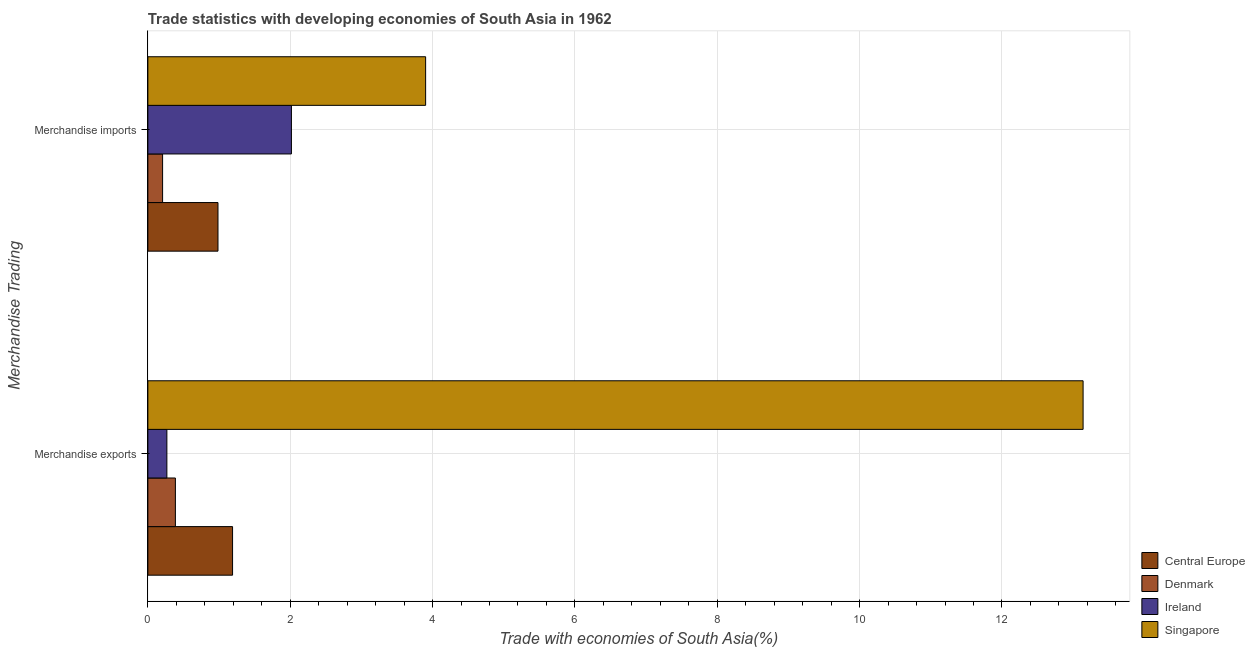How many different coloured bars are there?
Make the answer very short. 4. Are the number of bars per tick equal to the number of legend labels?
Make the answer very short. Yes. How many bars are there on the 1st tick from the top?
Your answer should be compact. 4. How many bars are there on the 2nd tick from the bottom?
Your response must be concise. 4. What is the label of the 2nd group of bars from the top?
Provide a succinct answer. Merchandise exports. What is the merchandise exports in Denmark?
Your answer should be very brief. 0.39. Across all countries, what is the maximum merchandise imports?
Make the answer very short. 3.9. Across all countries, what is the minimum merchandise imports?
Keep it short and to the point. 0.21. In which country was the merchandise imports maximum?
Provide a short and direct response. Singapore. In which country was the merchandise imports minimum?
Your response must be concise. Denmark. What is the total merchandise exports in the graph?
Provide a succinct answer. 14.98. What is the difference between the merchandise exports in Central Europe and that in Denmark?
Ensure brevity in your answer.  0.8. What is the difference between the merchandise exports in Denmark and the merchandise imports in Central Europe?
Provide a succinct answer. -0.6. What is the average merchandise exports per country?
Give a very brief answer. 3.75. What is the difference between the merchandise imports and merchandise exports in Singapore?
Ensure brevity in your answer.  -9.24. In how many countries, is the merchandise exports greater than 0.4 %?
Your answer should be very brief. 2. What is the ratio of the merchandise imports in Singapore to that in Ireland?
Make the answer very short. 1.93. What does the 2nd bar from the top in Merchandise exports represents?
Make the answer very short. Ireland. What does the 3rd bar from the bottom in Merchandise imports represents?
Provide a succinct answer. Ireland. How many bars are there?
Make the answer very short. 8. Are all the bars in the graph horizontal?
Provide a short and direct response. Yes. How many countries are there in the graph?
Offer a terse response. 4. Does the graph contain any zero values?
Give a very brief answer. No. Where does the legend appear in the graph?
Ensure brevity in your answer.  Bottom right. How many legend labels are there?
Keep it short and to the point. 4. What is the title of the graph?
Offer a terse response. Trade statistics with developing economies of South Asia in 1962. Does "Turkmenistan" appear as one of the legend labels in the graph?
Your answer should be compact. No. What is the label or title of the X-axis?
Provide a short and direct response. Trade with economies of South Asia(%). What is the label or title of the Y-axis?
Offer a terse response. Merchandise Trading. What is the Trade with economies of South Asia(%) of Central Europe in Merchandise exports?
Ensure brevity in your answer.  1.19. What is the Trade with economies of South Asia(%) of Denmark in Merchandise exports?
Ensure brevity in your answer.  0.39. What is the Trade with economies of South Asia(%) in Ireland in Merchandise exports?
Provide a succinct answer. 0.27. What is the Trade with economies of South Asia(%) of Singapore in Merchandise exports?
Offer a terse response. 13.14. What is the Trade with economies of South Asia(%) of Central Europe in Merchandise imports?
Keep it short and to the point. 0.99. What is the Trade with economies of South Asia(%) of Denmark in Merchandise imports?
Your answer should be very brief. 0.21. What is the Trade with economies of South Asia(%) of Ireland in Merchandise imports?
Offer a very short reply. 2.02. What is the Trade with economies of South Asia(%) of Singapore in Merchandise imports?
Your answer should be very brief. 3.9. Across all Merchandise Trading, what is the maximum Trade with economies of South Asia(%) of Central Europe?
Give a very brief answer. 1.19. Across all Merchandise Trading, what is the maximum Trade with economies of South Asia(%) of Denmark?
Your answer should be very brief. 0.39. Across all Merchandise Trading, what is the maximum Trade with economies of South Asia(%) in Ireland?
Your answer should be very brief. 2.02. Across all Merchandise Trading, what is the maximum Trade with economies of South Asia(%) of Singapore?
Make the answer very short. 13.14. Across all Merchandise Trading, what is the minimum Trade with economies of South Asia(%) of Central Europe?
Ensure brevity in your answer.  0.99. Across all Merchandise Trading, what is the minimum Trade with economies of South Asia(%) of Denmark?
Your answer should be compact. 0.21. Across all Merchandise Trading, what is the minimum Trade with economies of South Asia(%) in Ireland?
Ensure brevity in your answer.  0.27. Across all Merchandise Trading, what is the minimum Trade with economies of South Asia(%) in Singapore?
Provide a short and direct response. 3.9. What is the total Trade with economies of South Asia(%) of Central Europe in the graph?
Ensure brevity in your answer.  2.18. What is the total Trade with economies of South Asia(%) of Denmark in the graph?
Your answer should be compact. 0.59. What is the total Trade with economies of South Asia(%) of Ireland in the graph?
Your answer should be compact. 2.28. What is the total Trade with economies of South Asia(%) in Singapore in the graph?
Your response must be concise. 17.04. What is the difference between the Trade with economies of South Asia(%) in Central Europe in Merchandise exports and that in Merchandise imports?
Your answer should be compact. 0.2. What is the difference between the Trade with economies of South Asia(%) in Denmark in Merchandise exports and that in Merchandise imports?
Your response must be concise. 0.18. What is the difference between the Trade with economies of South Asia(%) of Ireland in Merchandise exports and that in Merchandise imports?
Offer a very short reply. -1.75. What is the difference between the Trade with economies of South Asia(%) in Singapore in Merchandise exports and that in Merchandise imports?
Your answer should be compact. 9.24. What is the difference between the Trade with economies of South Asia(%) in Central Europe in Merchandise exports and the Trade with economies of South Asia(%) in Denmark in Merchandise imports?
Provide a succinct answer. 0.98. What is the difference between the Trade with economies of South Asia(%) of Central Europe in Merchandise exports and the Trade with economies of South Asia(%) of Ireland in Merchandise imports?
Provide a succinct answer. -0.83. What is the difference between the Trade with economies of South Asia(%) in Central Europe in Merchandise exports and the Trade with economies of South Asia(%) in Singapore in Merchandise imports?
Keep it short and to the point. -2.71. What is the difference between the Trade with economies of South Asia(%) of Denmark in Merchandise exports and the Trade with economies of South Asia(%) of Ireland in Merchandise imports?
Keep it short and to the point. -1.63. What is the difference between the Trade with economies of South Asia(%) in Denmark in Merchandise exports and the Trade with economies of South Asia(%) in Singapore in Merchandise imports?
Provide a short and direct response. -3.52. What is the difference between the Trade with economies of South Asia(%) of Ireland in Merchandise exports and the Trade with economies of South Asia(%) of Singapore in Merchandise imports?
Offer a terse response. -3.64. What is the average Trade with economies of South Asia(%) of Central Europe per Merchandise Trading?
Make the answer very short. 1.09. What is the average Trade with economies of South Asia(%) of Denmark per Merchandise Trading?
Offer a very short reply. 0.3. What is the average Trade with economies of South Asia(%) of Ireland per Merchandise Trading?
Give a very brief answer. 1.14. What is the average Trade with economies of South Asia(%) of Singapore per Merchandise Trading?
Your answer should be compact. 8.52. What is the difference between the Trade with economies of South Asia(%) of Central Europe and Trade with economies of South Asia(%) of Denmark in Merchandise exports?
Keep it short and to the point. 0.8. What is the difference between the Trade with economies of South Asia(%) in Central Europe and Trade with economies of South Asia(%) in Ireland in Merchandise exports?
Make the answer very short. 0.92. What is the difference between the Trade with economies of South Asia(%) in Central Europe and Trade with economies of South Asia(%) in Singapore in Merchandise exports?
Offer a very short reply. -11.95. What is the difference between the Trade with economies of South Asia(%) of Denmark and Trade with economies of South Asia(%) of Ireland in Merchandise exports?
Provide a short and direct response. 0.12. What is the difference between the Trade with economies of South Asia(%) in Denmark and Trade with economies of South Asia(%) in Singapore in Merchandise exports?
Your answer should be very brief. -12.75. What is the difference between the Trade with economies of South Asia(%) of Ireland and Trade with economies of South Asia(%) of Singapore in Merchandise exports?
Provide a succinct answer. -12.87. What is the difference between the Trade with economies of South Asia(%) in Central Europe and Trade with economies of South Asia(%) in Denmark in Merchandise imports?
Provide a succinct answer. 0.78. What is the difference between the Trade with economies of South Asia(%) in Central Europe and Trade with economies of South Asia(%) in Ireland in Merchandise imports?
Offer a terse response. -1.03. What is the difference between the Trade with economies of South Asia(%) in Central Europe and Trade with economies of South Asia(%) in Singapore in Merchandise imports?
Offer a terse response. -2.92. What is the difference between the Trade with economies of South Asia(%) in Denmark and Trade with economies of South Asia(%) in Ireland in Merchandise imports?
Offer a terse response. -1.81. What is the difference between the Trade with economies of South Asia(%) in Denmark and Trade with economies of South Asia(%) in Singapore in Merchandise imports?
Your answer should be compact. -3.7. What is the difference between the Trade with economies of South Asia(%) of Ireland and Trade with economies of South Asia(%) of Singapore in Merchandise imports?
Make the answer very short. -1.89. What is the ratio of the Trade with economies of South Asia(%) in Central Europe in Merchandise exports to that in Merchandise imports?
Keep it short and to the point. 1.21. What is the ratio of the Trade with economies of South Asia(%) in Denmark in Merchandise exports to that in Merchandise imports?
Provide a succinct answer. 1.87. What is the ratio of the Trade with economies of South Asia(%) of Ireland in Merchandise exports to that in Merchandise imports?
Offer a very short reply. 0.13. What is the ratio of the Trade with economies of South Asia(%) of Singapore in Merchandise exports to that in Merchandise imports?
Offer a very short reply. 3.37. What is the difference between the highest and the second highest Trade with economies of South Asia(%) of Central Europe?
Make the answer very short. 0.2. What is the difference between the highest and the second highest Trade with economies of South Asia(%) of Denmark?
Your response must be concise. 0.18. What is the difference between the highest and the second highest Trade with economies of South Asia(%) of Ireland?
Offer a very short reply. 1.75. What is the difference between the highest and the second highest Trade with economies of South Asia(%) of Singapore?
Provide a short and direct response. 9.24. What is the difference between the highest and the lowest Trade with economies of South Asia(%) of Central Europe?
Your answer should be very brief. 0.2. What is the difference between the highest and the lowest Trade with economies of South Asia(%) of Denmark?
Your answer should be compact. 0.18. What is the difference between the highest and the lowest Trade with economies of South Asia(%) in Ireland?
Your answer should be compact. 1.75. What is the difference between the highest and the lowest Trade with economies of South Asia(%) in Singapore?
Your answer should be very brief. 9.24. 